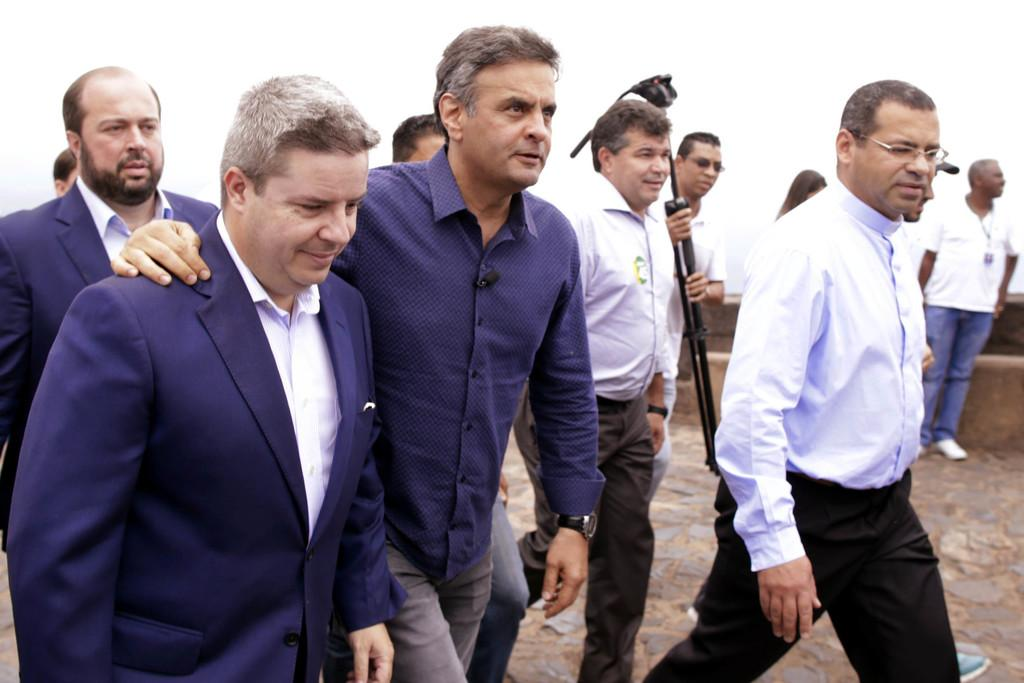What are the people in the image doing? The people in the image are walking. Can you describe the person holding sticks? One person is holding sticks and walking. What is at the bottom of the image? There is a walkway at the bottom of the image. What can be seen in the background of the image? There is a wall in the background of the image. How many suits can be seen hanging on the wall in the image? There is no suit present in the image; it only features people walking and a wall in the background. 